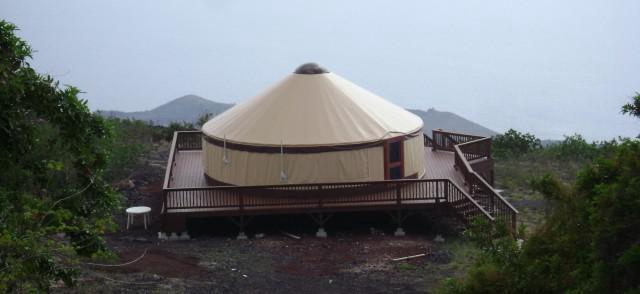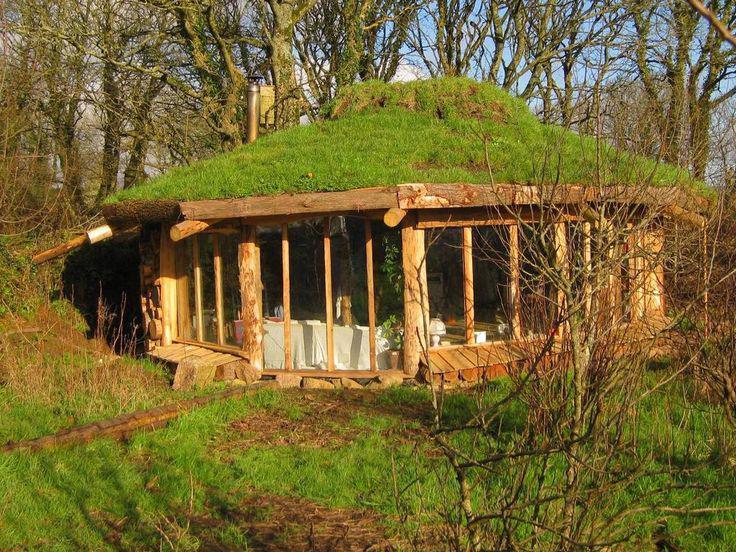The first image is the image on the left, the second image is the image on the right. Evaluate the accuracy of this statement regarding the images: "The image on the right contains stairs.". Is it true? Answer yes or no. No. 